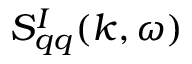Convert formula to latex. <formula><loc_0><loc_0><loc_500><loc_500>S _ { q q } ^ { I } ( k , \omega )</formula> 